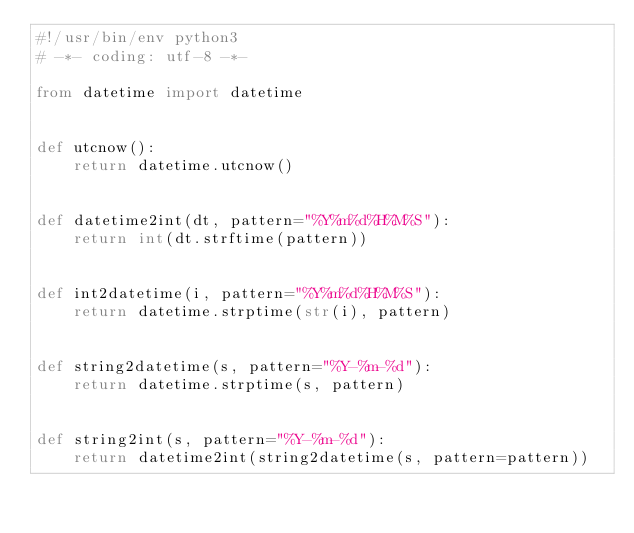Convert code to text. <code><loc_0><loc_0><loc_500><loc_500><_Python_>#!/usr/bin/env python3
# -*- coding: utf-8 -*-

from datetime import datetime


def utcnow():
    return datetime.utcnow()


def datetime2int(dt, pattern="%Y%m%d%H%M%S"):
    return int(dt.strftime(pattern))


def int2datetime(i, pattern="%Y%m%d%H%M%S"):
    return datetime.strptime(str(i), pattern)


def string2datetime(s, pattern="%Y-%m-%d"):
    return datetime.strptime(s, pattern)


def string2int(s, pattern="%Y-%m-%d"):
    return datetime2int(string2datetime(s, pattern=pattern))
</code> 